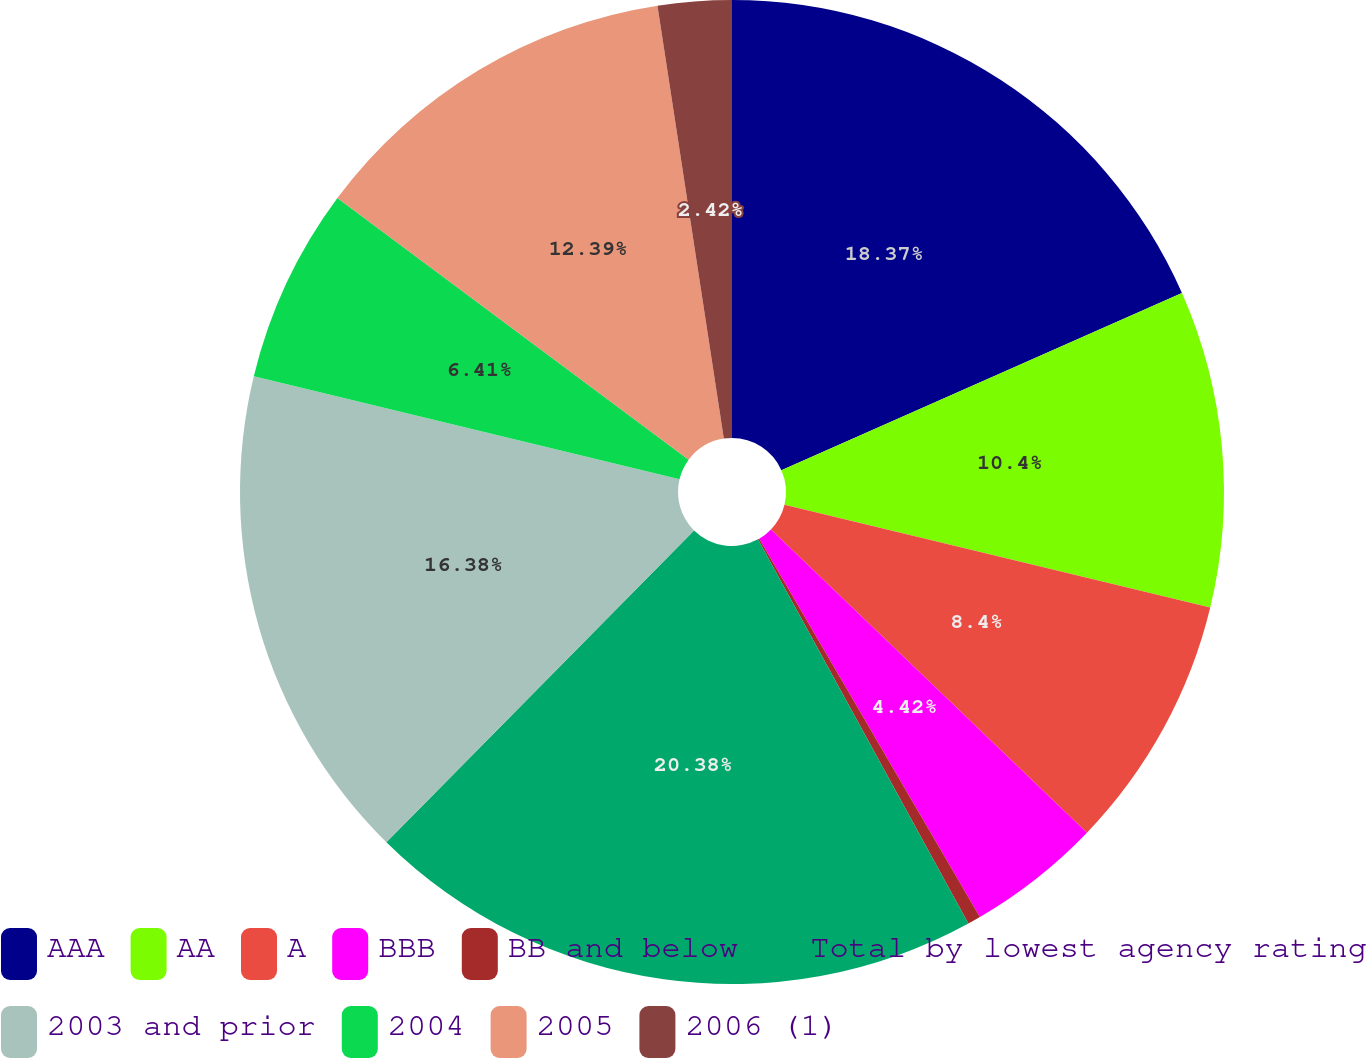Convert chart. <chart><loc_0><loc_0><loc_500><loc_500><pie_chart><fcel>AAA<fcel>AA<fcel>A<fcel>BBB<fcel>BB and below<fcel>Total by lowest agency rating<fcel>2003 and prior<fcel>2004<fcel>2005<fcel>2006 (1)<nl><fcel>18.37%<fcel>10.4%<fcel>8.4%<fcel>4.42%<fcel>0.43%<fcel>20.37%<fcel>16.38%<fcel>6.41%<fcel>12.39%<fcel>2.42%<nl></chart> 